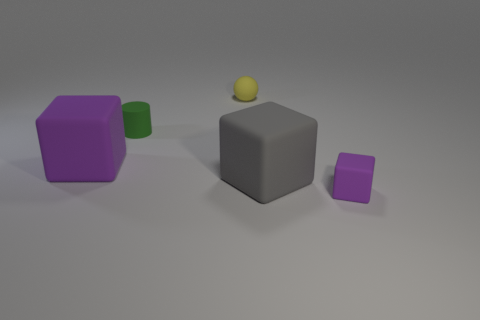Add 5 small yellow matte objects. How many objects exist? 10 Subtract all balls. How many objects are left? 4 Subtract 0 cyan cubes. How many objects are left? 5 Subtract all tiny matte blocks. Subtract all cylinders. How many objects are left? 3 Add 5 gray matte cubes. How many gray matte cubes are left? 6 Add 5 big rubber objects. How many big rubber objects exist? 7 